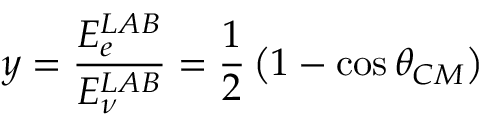Convert formula to latex. <formula><loc_0><loc_0><loc_500><loc_500>y = \frac { E _ { e } ^ { L A B } } { E _ { \nu } ^ { L A B } } = \frac { 1 } { 2 } \left ( 1 - \cos \theta _ { C M } \right )</formula> 